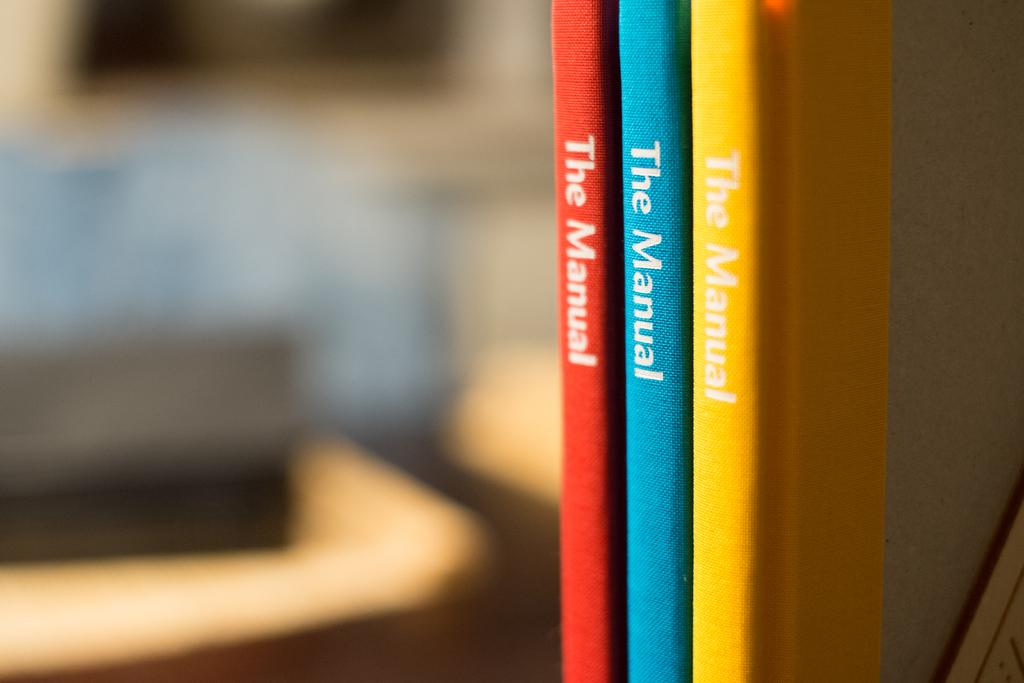What are these books called?
Keep it short and to the point. The manual. 